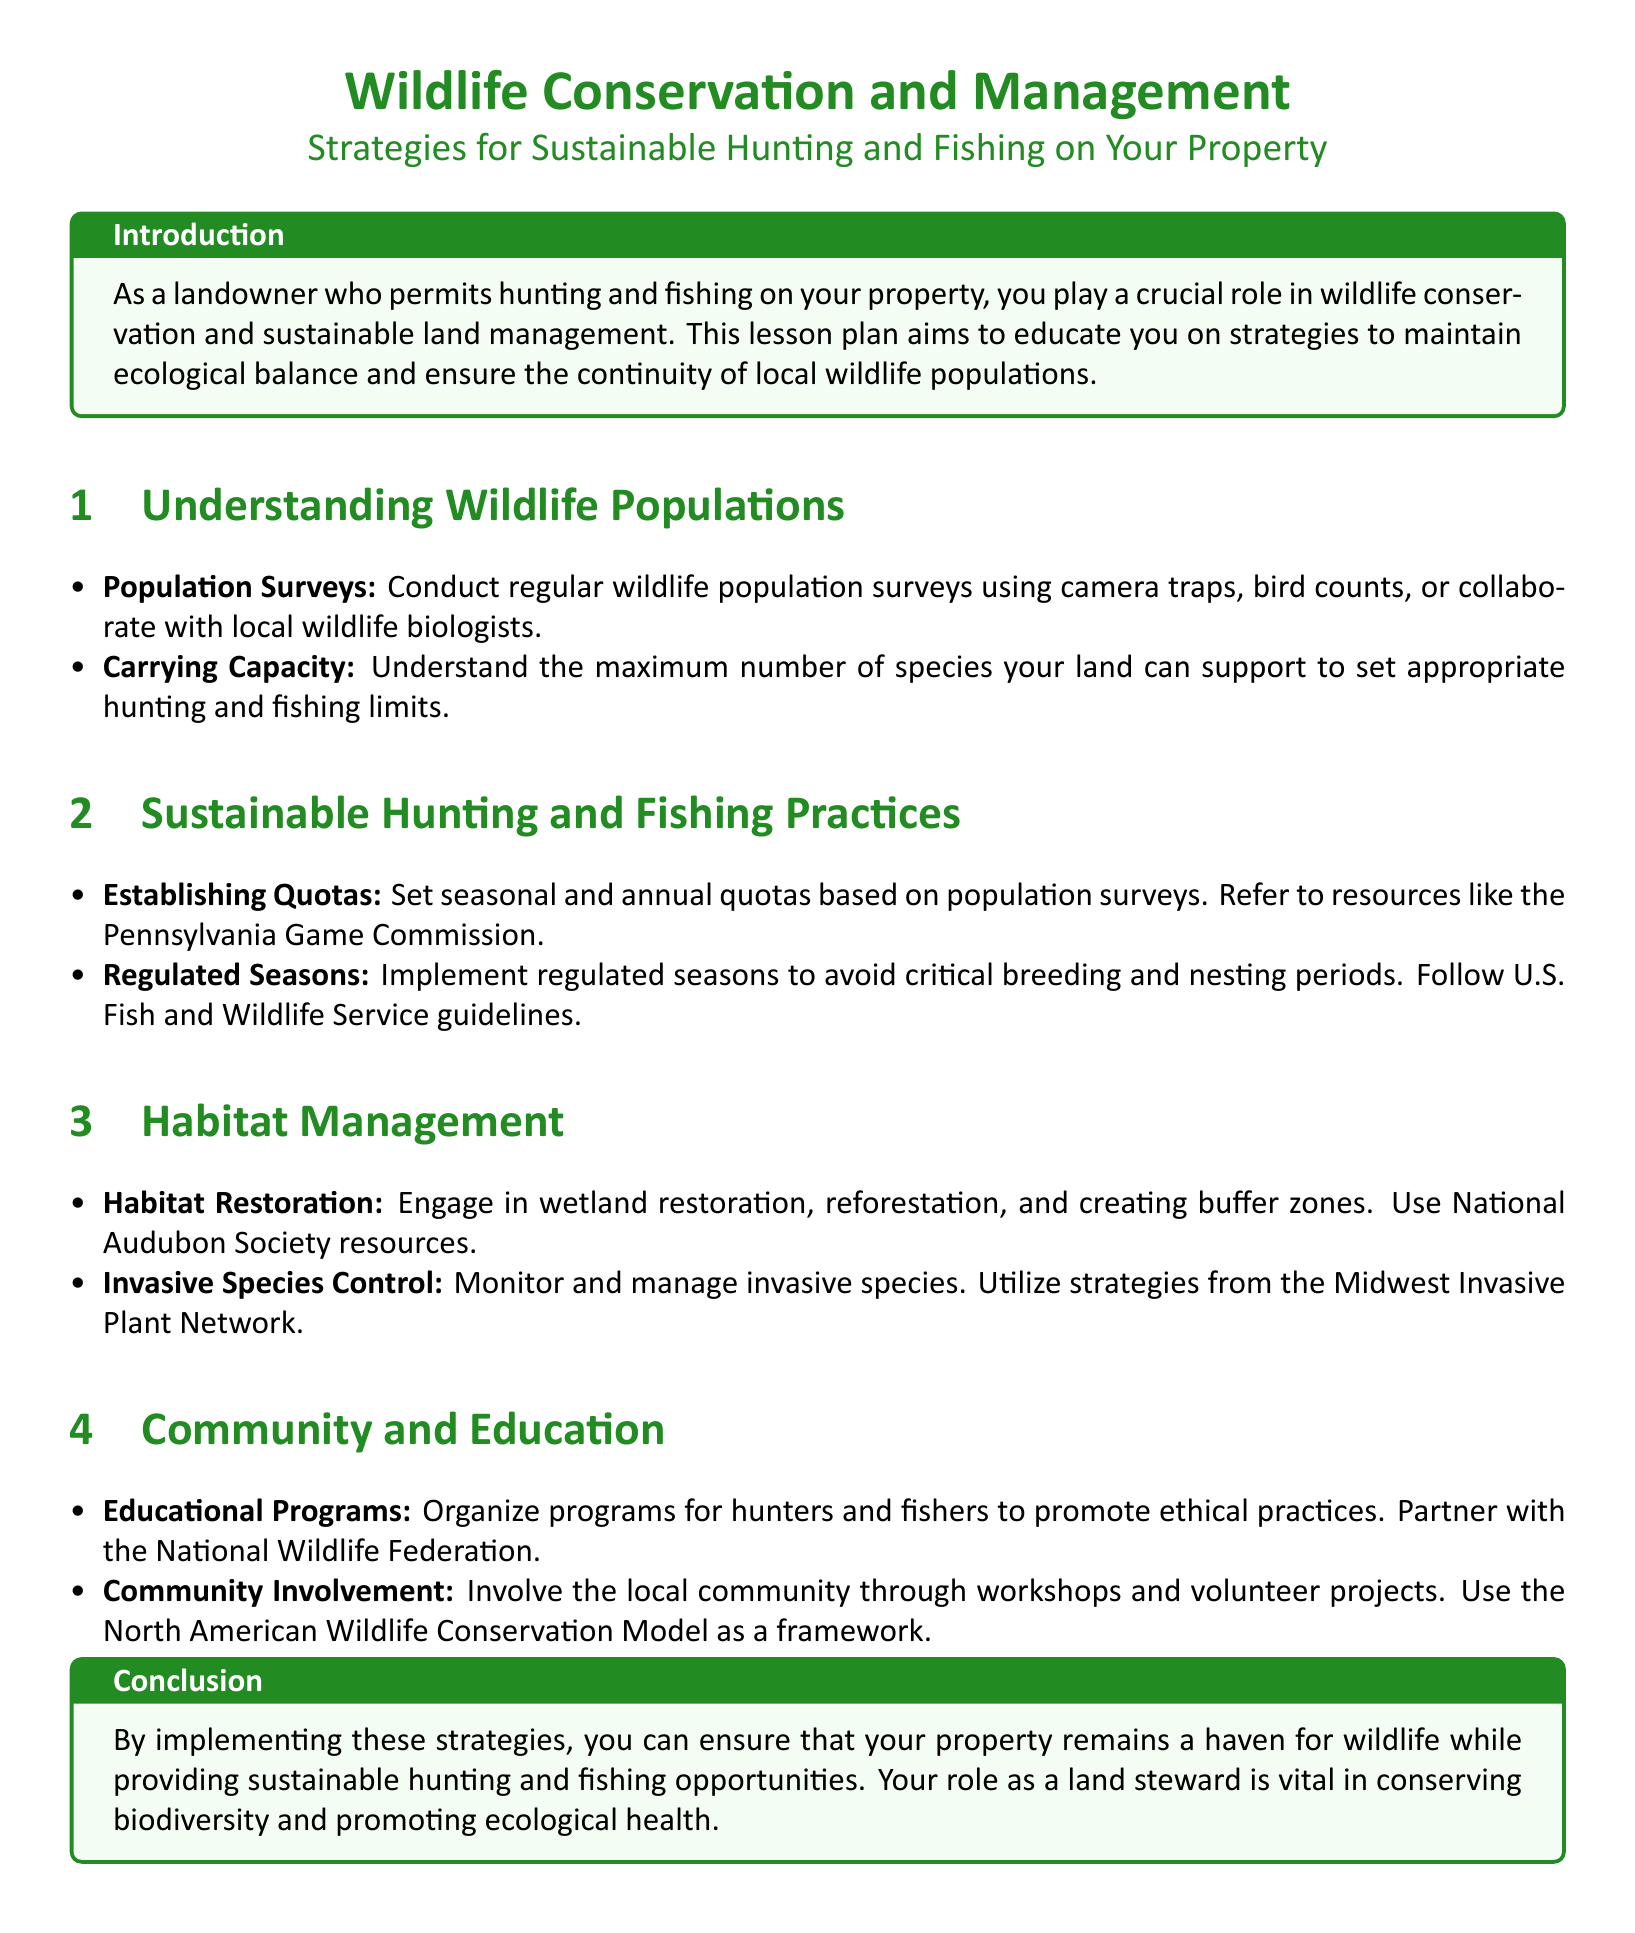What is the title of the lesson plan? The title provides a summary of the focus of the document, specifically about wildlife conservation and sustainable practices for hunting and fishing.
Answer: Wildlife Conservation and Management: Strategies for Sustainable Hunting and Fishing on Your Property What is the first section of the lesson plan? The first section discusses the fundamental aspects of wildlife populations which are key to understanding conservation efforts.
Answer: Understanding Wildlife Populations How often should wildlife population surveys be conducted? The document highlights the importance of conducting these surveys regularly for effective management practices.
Answer: Regularly What organization is referenced for setting hunting quotas? The document provides a specific resource that landowners can consult for establishing appropriate hunting limits based on wildlife populations.
Answer: Pennsylvania Game Commission What is one strategy for invasive species control? The document mentions the need to monitor and manage invasive species as part of habitat management practices.
Answer: Monitor and manage Which society's resources can help with habitat restoration? The document names a specific organization that provides valuable information for landowners engaged in habitat restoration efforts.
Answer: National Audubon Society What is the role of the landowner according to the conclusion? The conclusion emphasizes the importance of the landowner's involvement in fostering ecological health and conserving wildlife.
Answer: Land steward What does community involvement include? The document suggests organizing local activities that encourage community participation in wildlife conservation initiatives.
Answer: Workshops and volunteer projects What should educational programs promote? This question focuses on the intended goal of the programs described in the lesson plan to support sustainable practices.
Answer: Ethical practices 